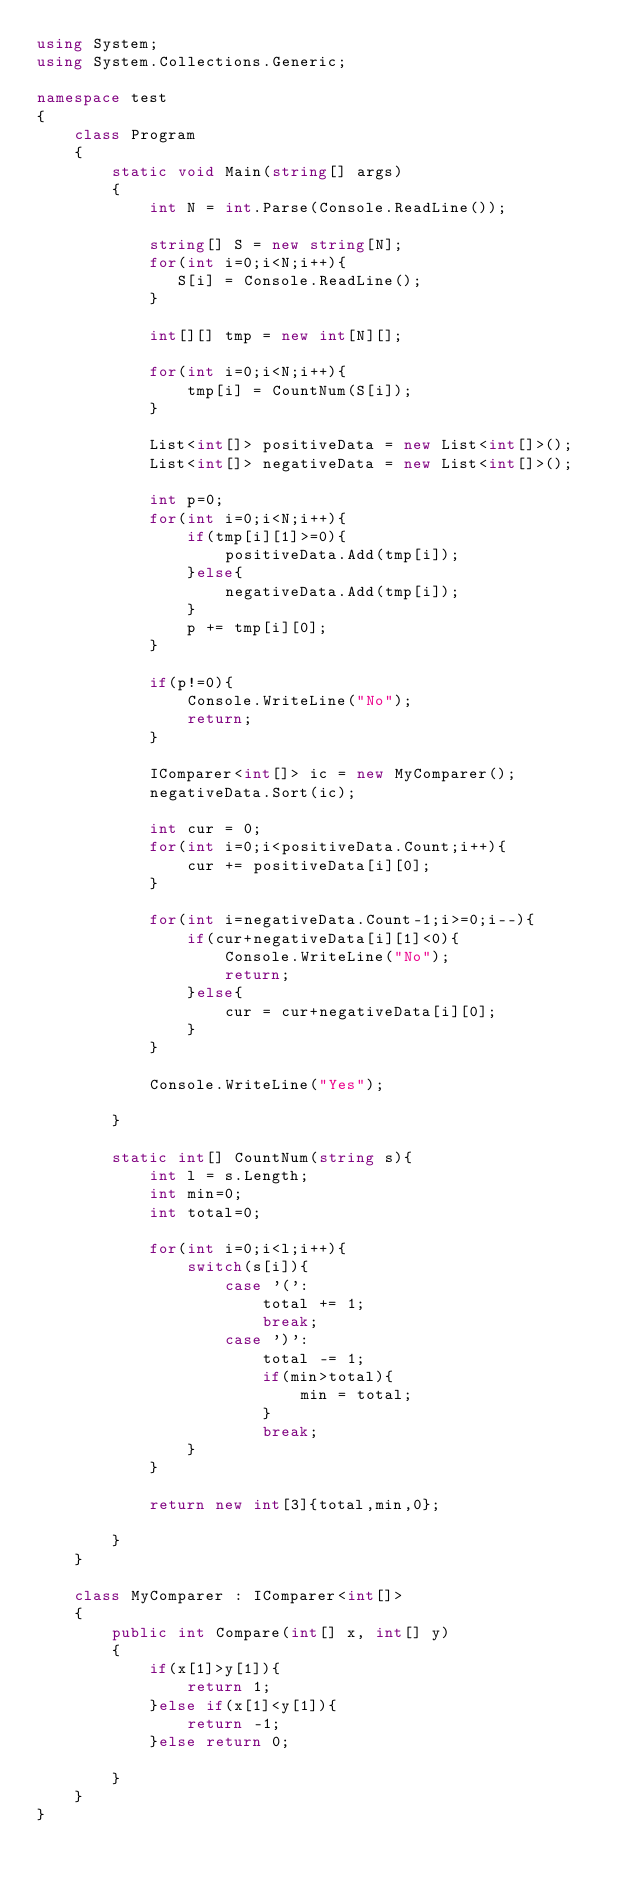<code> <loc_0><loc_0><loc_500><loc_500><_C#_>using System;
using System.Collections.Generic;

namespace test
{
    class Program
    {
        static void Main(string[] args)
        {
            int N = int.Parse(Console.ReadLine());

            string[] S = new string[N];
            for(int i=0;i<N;i++){
               S[i] = Console.ReadLine();
            }

            int[][] tmp = new int[N][];

            for(int i=0;i<N;i++){
                tmp[i] = CountNum(S[i]);
            }

            List<int[]> positiveData = new List<int[]>();
            List<int[]> negativeData = new List<int[]>();

            int p=0;
            for(int i=0;i<N;i++){
                if(tmp[i][1]>=0){
                    positiveData.Add(tmp[i]);
                }else{
                    negativeData.Add(tmp[i]);
                }
                p += tmp[i][0];
            }

            if(p!=0){
                Console.WriteLine("No");
                return;
            }

            IComparer<int[]> ic = new MyComparer();
            negativeData.Sort(ic);

            int cur = 0;   
            for(int i=0;i<positiveData.Count;i++){
                cur += positiveData[i][0];
            }

            for(int i=negativeData.Count-1;i>=0;i--){
                if(cur+negativeData[i][1]<0){
                    Console.WriteLine("No");
                    return;
                }else{
                    cur = cur+negativeData[i][0];
                }
            }

            Console.WriteLine("Yes");

        }
        
        static int[] CountNum(string s){
            int l = s.Length;
            int min=0;
            int total=0;

            for(int i=0;i<l;i++){
                switch(s[i]){
                    case '(':
                        total += 1;
                        break;
                    case ')':
                        total -= 1;
                        if(min>total){
                            min = total;
                        }
                        break;
                }
            }

            return new int[3]{total,min,0};

        }
    }

    class MyComparer : IComparer<int[]>
    {
        public int Compare(int[] x, int[] y)
        {
            if(x[1]>y[1]){
                return 1;
            }else if(x[1]<y[1]){
                return -1;
            }else return 0;

        }
    }
}
</code> 